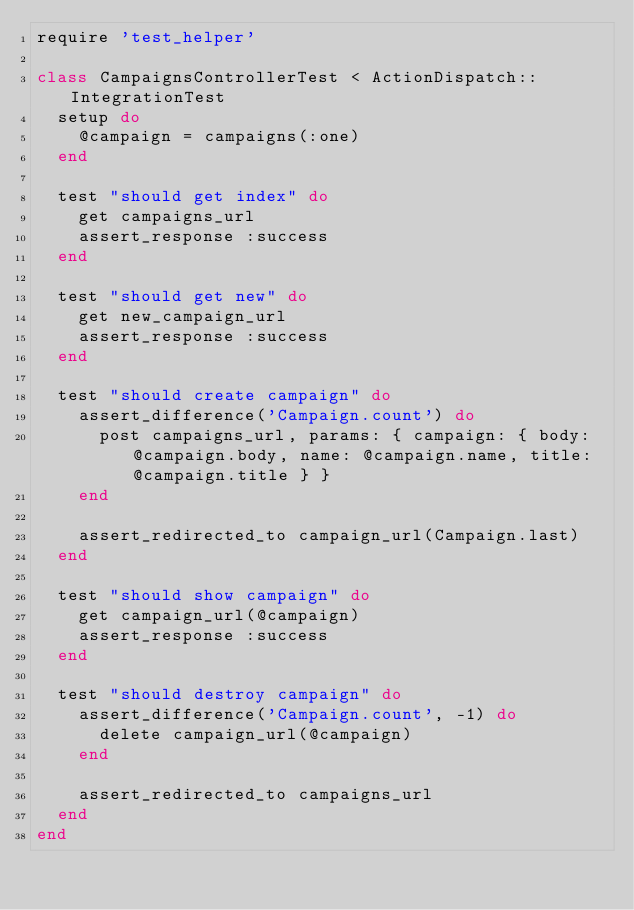Convert code to text. <code><loc_0><loc_0><loc_500><loc_500><_Ruby_>require 'test_helper'

class CampaignsControllerTest < ActionDispatch::IntegrationTest
  setup do
    @campaign = campaigns(:one)
  end

  test "should get index" do
    get campaigns_url
    assert_response :success
  end

  test "should get new" do
    get new_campaign_url
    assert_response :success
  end

  test "should create campaign" do
    assert_difference('Campaign.count') do
      post campaigns_url, params: { campaign: { body: @campaign.body, name: @campaign.name, title: @campaign.title } }
    end

    assert_redirected_to campaign_url(Campaign.last)
  end

  test "should show campaign" do
    get campaign_url(@campaign)
    assert_response :success
  end

  test "should destroy campaign" do
    assert_difference('Campaign.count', -1) do
      delete campaign_url(@campaign)
    end

    assert_redirected_to campaigns_url
  end
end
</code> 